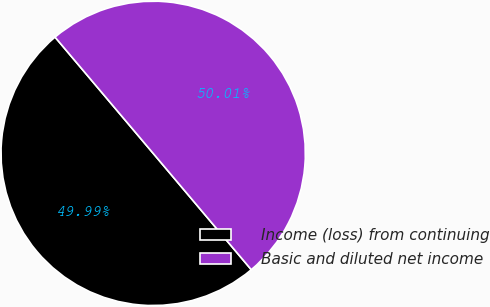Convert chart to OTSL. <chart><loc_0><loc_0><loc_500><loc_500><pie_chart><fcel>Income (loss) from continuing<fcel>Basic and diluted net income<nl><fcel>49.99%<fcel>50.01%<nl></chart> 